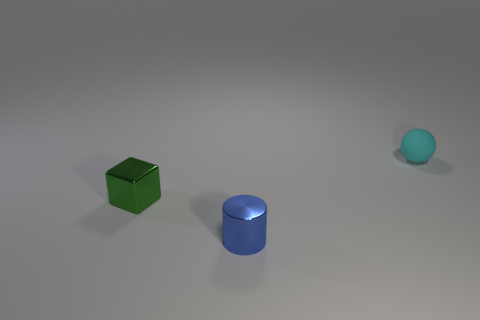Add 2 tiny cyan balls. How many objects exist? 5 Subtract all cylinders. How many objects are left? 2 Subtract all big cyan matte things. Subtract all tiny green objects. How many objects are left? 2 Add 3 green shiny cubes. How many green shiny cubes are left? 4 Add 2 cyan rubber cylinders. How many cyan rubber cylinders exist? 2 Subtract 0 cyan cylinders. How many objects are left? 3 